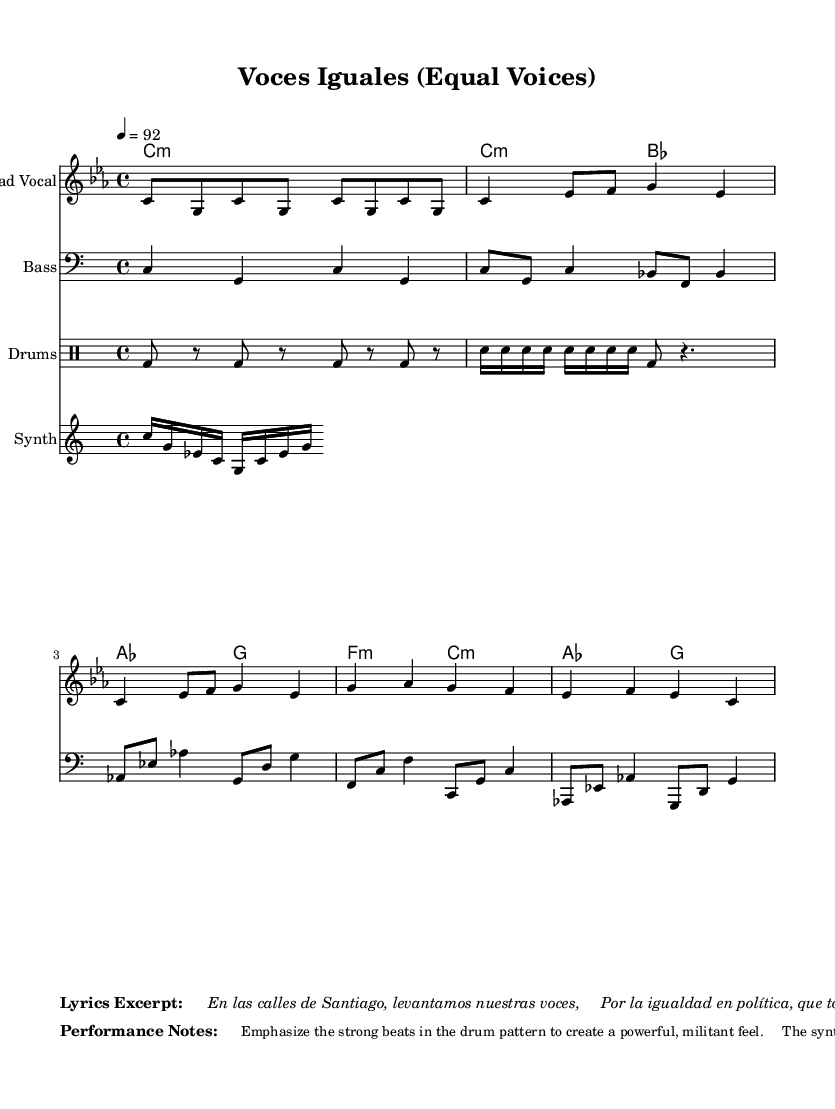What is the key signature of this music? The key signature is C minor, as indicated at the beginning of the score, which includes three flats.
Answer: C minor What is the time signature? The time signature is 4/4, noted at the start of the score and indicates a strong, steady beat with four beats per measure.
Answer: 4/4 What is the tempo of the piece? The tempo is 92 beats per minute, as specified at the beginning of the score with the marking "4 = 92".
Answer: 92 How many bars are in the chorus section? The chorus section has 4 bars, and this can be counted based on the measure lines in the music.
Answer: 4 bars What instruments are included in the score? The instruments are Lead Vocal, Bass, Drums, and Synth, as named in their respective staves at the beginning of each section.
Answer: Lead Vocal, Bass, Drums, Synth What is the main theme of the lyrics excerpt? The main theme of the lyrics excerpt focuses on equality in politics, specifically calling out for equal voices and gender representation, as portrayed in the lines provided.
Answer: Equality in politics What is the significance of the drum pattern in this rap piece? The drum pattern is designed to create a powerful, militant feel, which is typical for rap music to emphasize strong beats and drive the rhythm.
Answer: Powerful, militant feel 